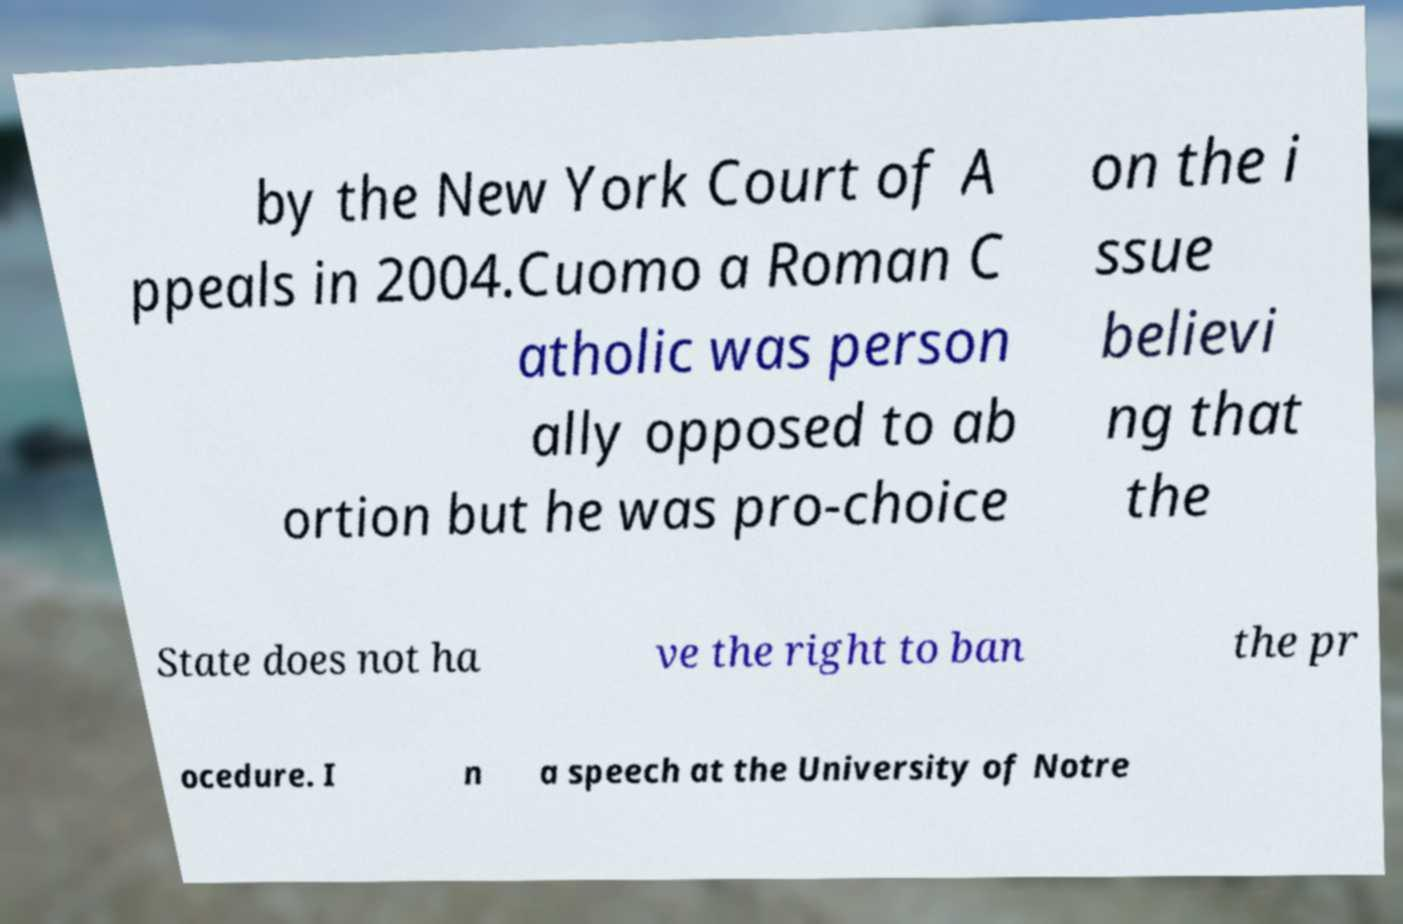Could you extract and type out the text from this image? by the New York Court of A ppeals in 2004.Cuomo a Roman C atholic was person ally opposed to ab ortion but he was pro-choice on the i ssue believi ng that the State does not ha ve the right to ban the pr ocedure. I n a speech at the University of Notre 